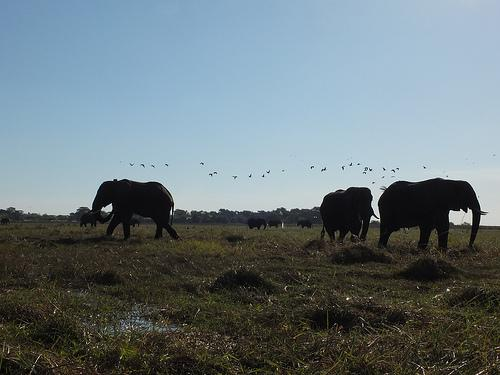Write a brief summary of the significant elements in the picture. The photo features elephants grazing, a grassy landscape, a clear sky, birds flying, and puddles of water. Craft a simple statement highlighting the main subjects and their activities in the image. Elephants graze peacefully in a field, while above them, birds glide through the clear blue sky. Explain what you notice first when looking at the image and its surroundings. A group of elephants are grazing in a green field, surrounded by a clear sky, flying birds, and puddles of water. Provide a concise description of the primary scene in the image. Elephants are grazing in a grassy field with a clear blue sky and birds flying above. Write a brief description emphasizing the setting of the image. In this idyllic scene, elephants are grazing in a grassy area under a clear blue sky, with birds flying overhead. Compose a concise statement mentioning the dominant subject and their surrounding environment. Elephants are grazing in a picturesque field, accompanied by a clear sky and birds soaring through the air. Mention the primary subject in the image along with the background details. Elephants are the main subject, grazing in a grassy landscape with a clear blue sky, birds flying, and puddles in the ground. Summarize what's happening in the image in a single sentence. Grazing elephants share a grassy landscape with airborne birds under a vast blue sky. Describe the most important elements of the image in one sentence. The image captures elephants grazing in a grassy field under a clear blue sky with birds flying above. Create a simple sentence that captures the main focus of the image. Elephants graze in a field as birds soar in the clear blue sky above. 